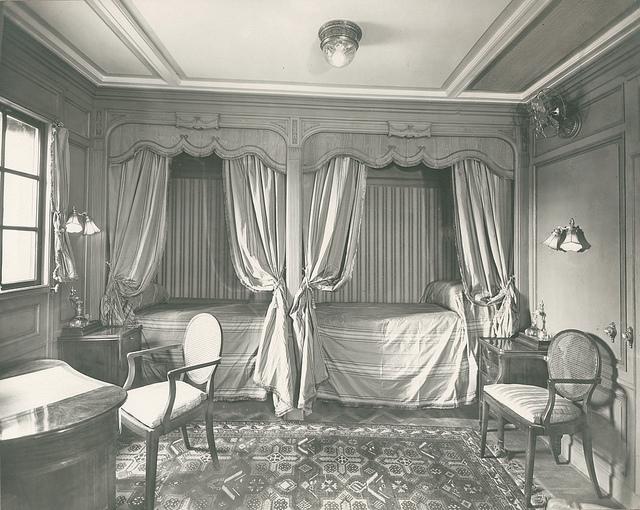How many beds are there?
Keep it brief. 2. Is this an old picture?
Give a very brief answer. Yes. Is this room a bedroom or bathroom?
Give a very brief answer. Bedroom. 